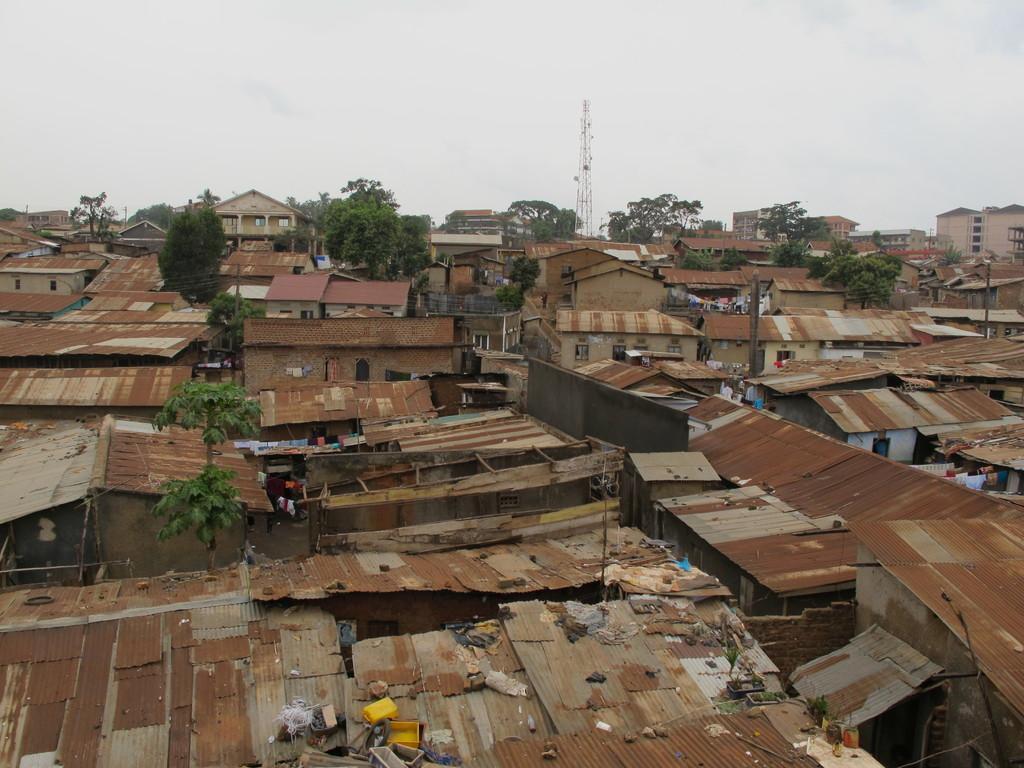In one or two sentences, can you explain what this image depicts? In this picture we can see a top view of the smaller shut houses. Behind we can see some trees and electric tower. On the top there is a sky and clouds. 